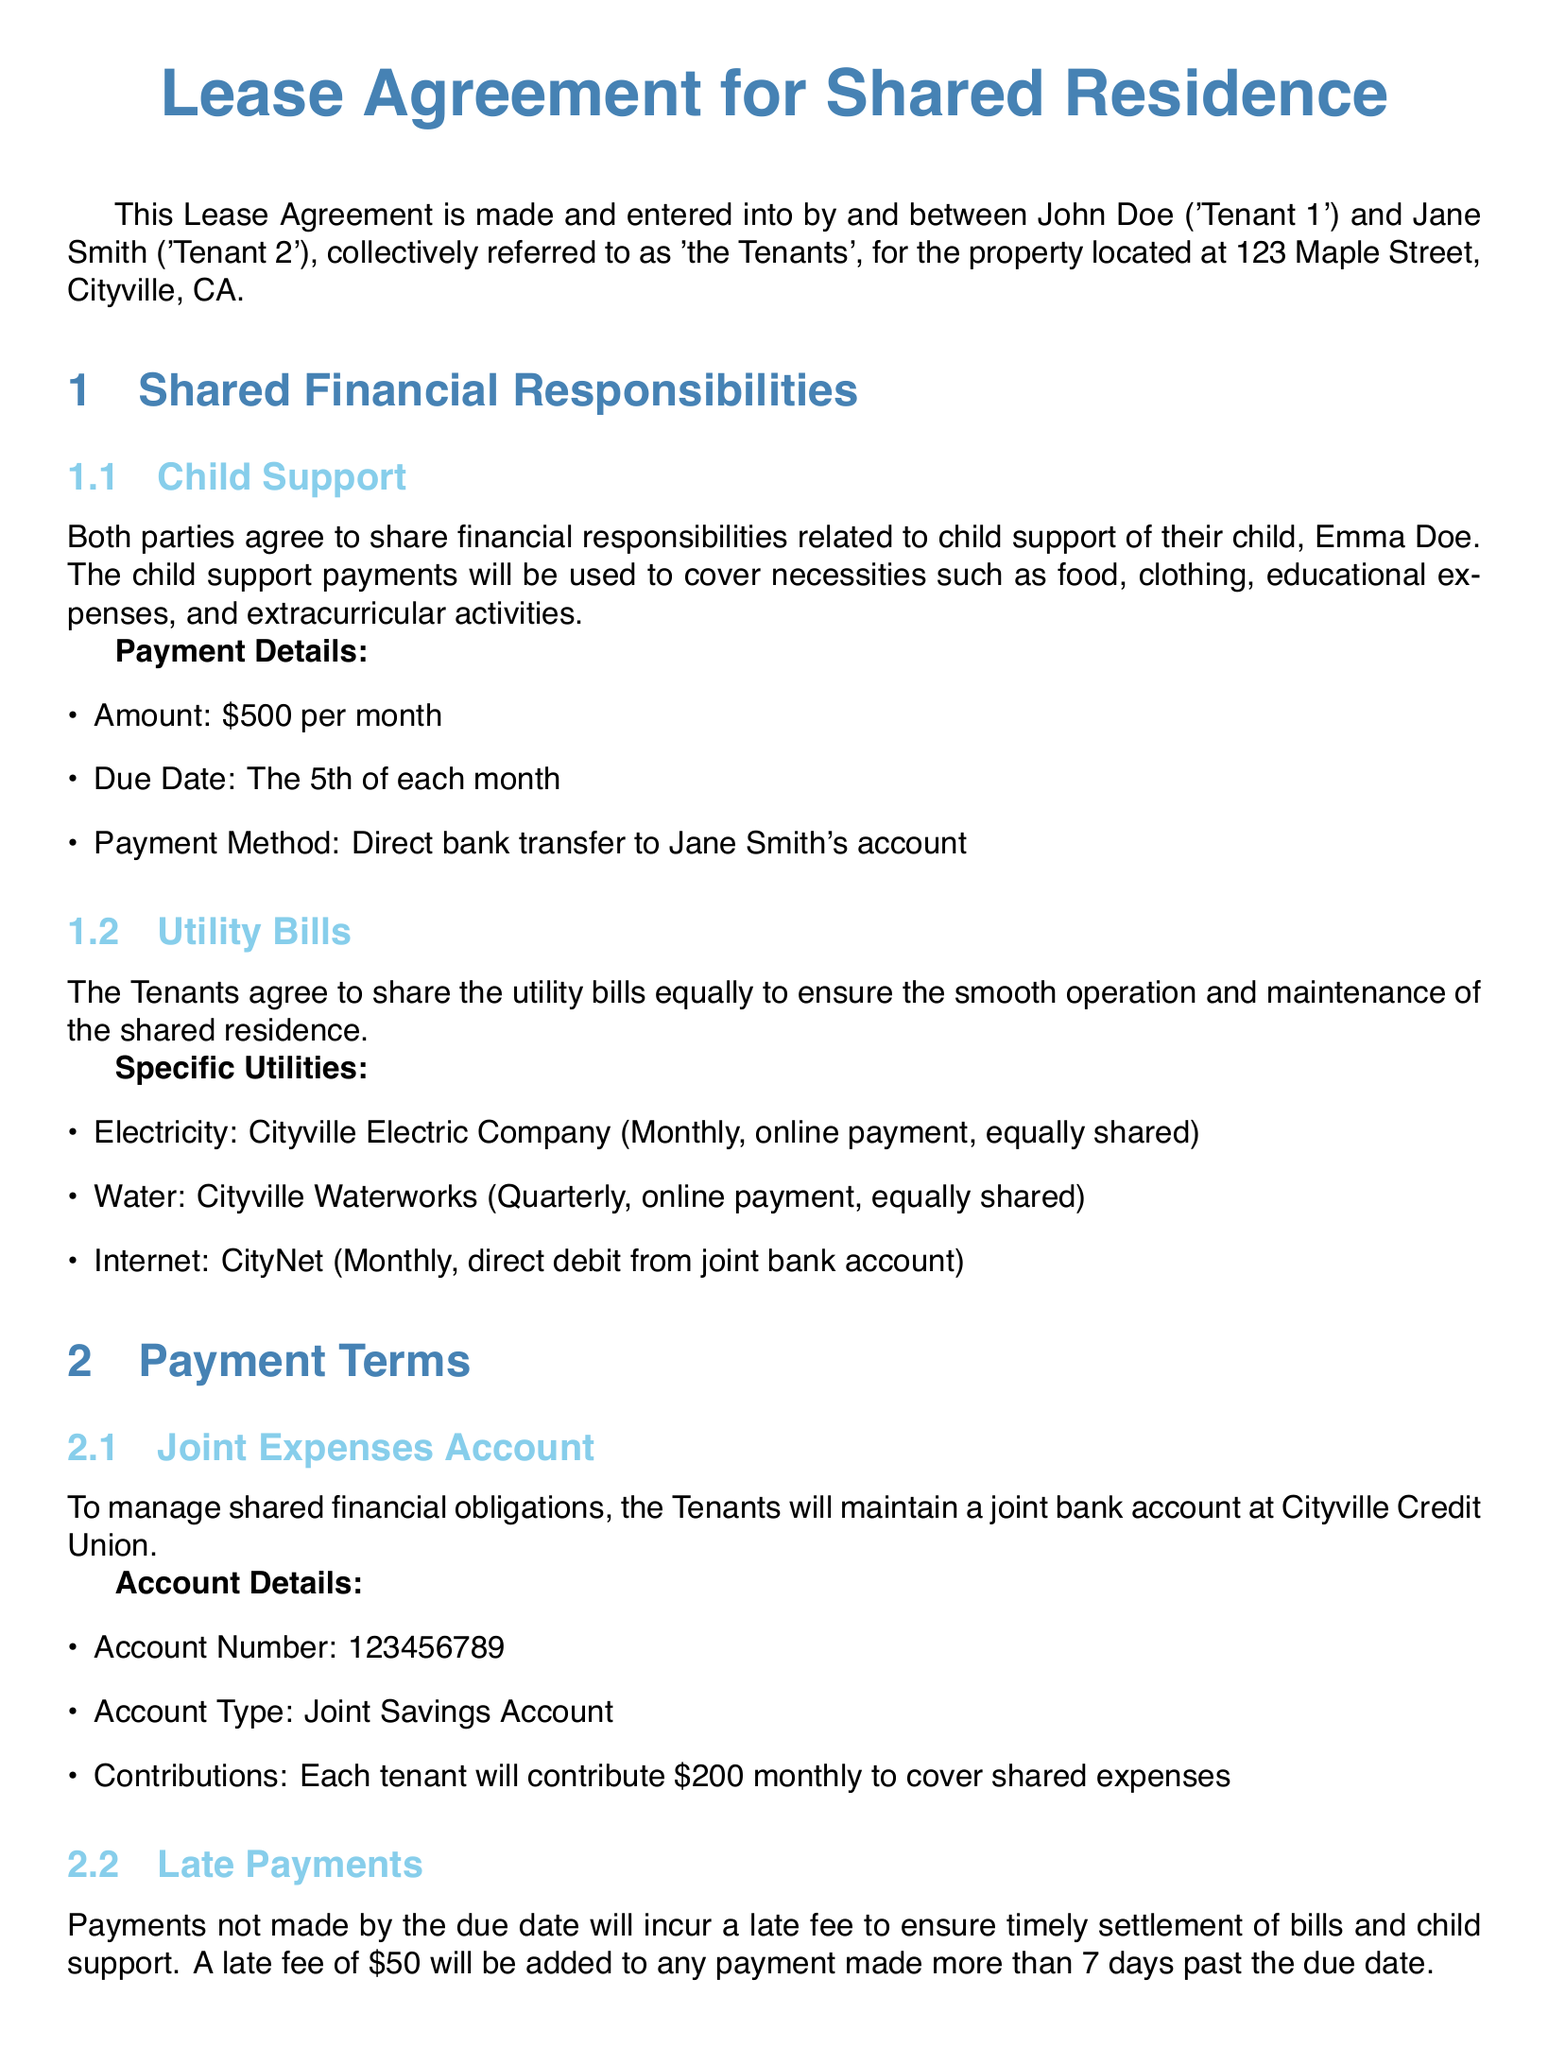What is the amount for child support? The document specifies the child support payment amount as $500 per month.
Answer: $500 What is due date for child support payments? The lease agreement states that child support payments are due on the 5th of each month.
Answer: The 5th of each month Who receives the child support payments? The document indicates that child support payments are to be made directly to Jane Smith's account.
Answer: Jane Smith How often are the utility bills paid? The lease agreement mentions that electricity is paid monthly, water quarterly, and internet monthly.
Answer: Monthly and quarterly What is the late fee for missed payments? According to the lease agreement, any payment made more than 7 days past the due date incurs a late fee of $50.
Answer: $50 What type of account is used for joint expenses? The document specifies that a joint savings account is maintained for managing shared financial obligations.
Answer: Joint Savings Account What is the monthly contribution by each tenant? The lease agreement states that each tenant will contribute $200 monthly to cover shared expenses.
Answer: $200 How many days notice is required to terminate the agreement? The document states that either tenant must provide 30 days written notice to terminate the agreement.
Answer: 30 days 